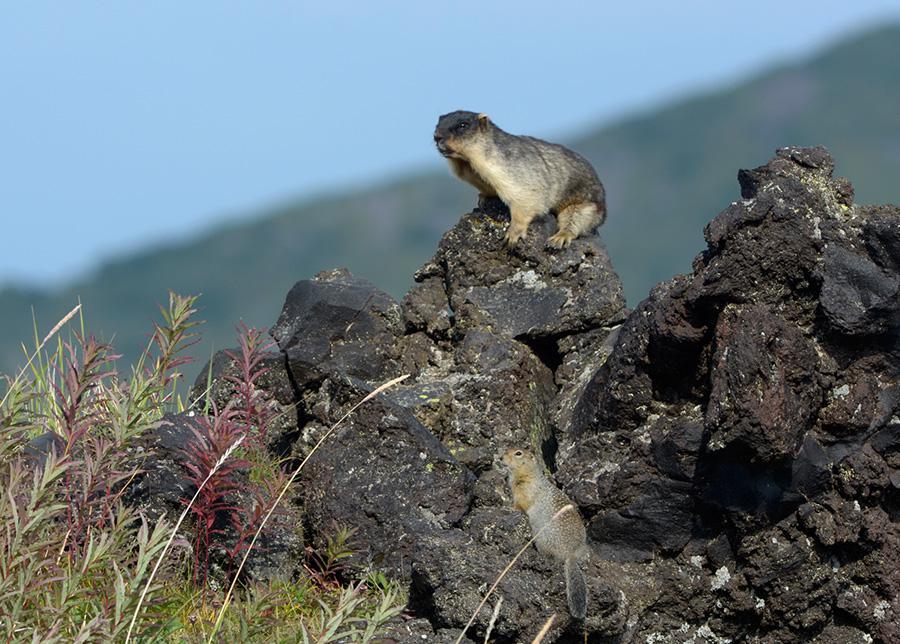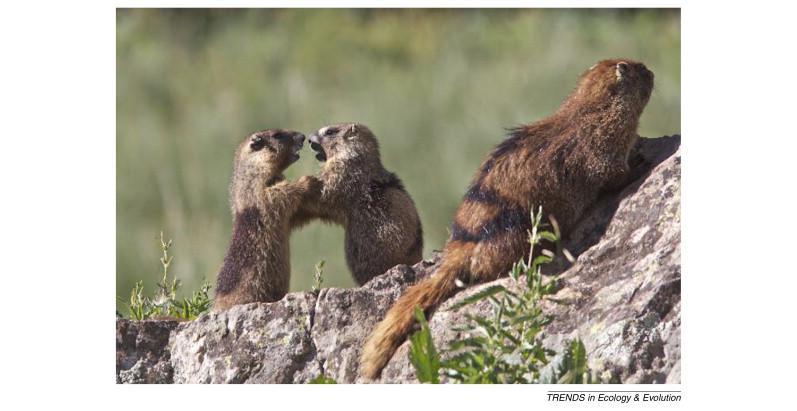The first image is the image on the left, the second image is the image on the right. Analyze the images presented: Is the assertion "Each image contains one pair of marmots posed close together on a rock, and no marmots have their backs to the camera." valid? Answer yes or no. No. The first image is the image on the left, the second image is the image on the right. Given the left and right images, does the statement "On the right image, the two animals are facing the same direction." hold true? Answer yes or no. No. 